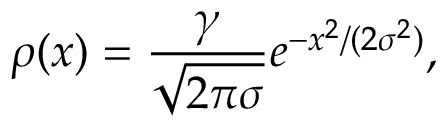<formula> <loc_0><loc_0><loc_500><loc_500>\rho ( x ) = \frac { \gamma } { \sqrt { 2 \pi \sigma } } e ^ { - x ^ { 2 } / ( 2 \sigma ^ { 2 } ) } ,</formula> 